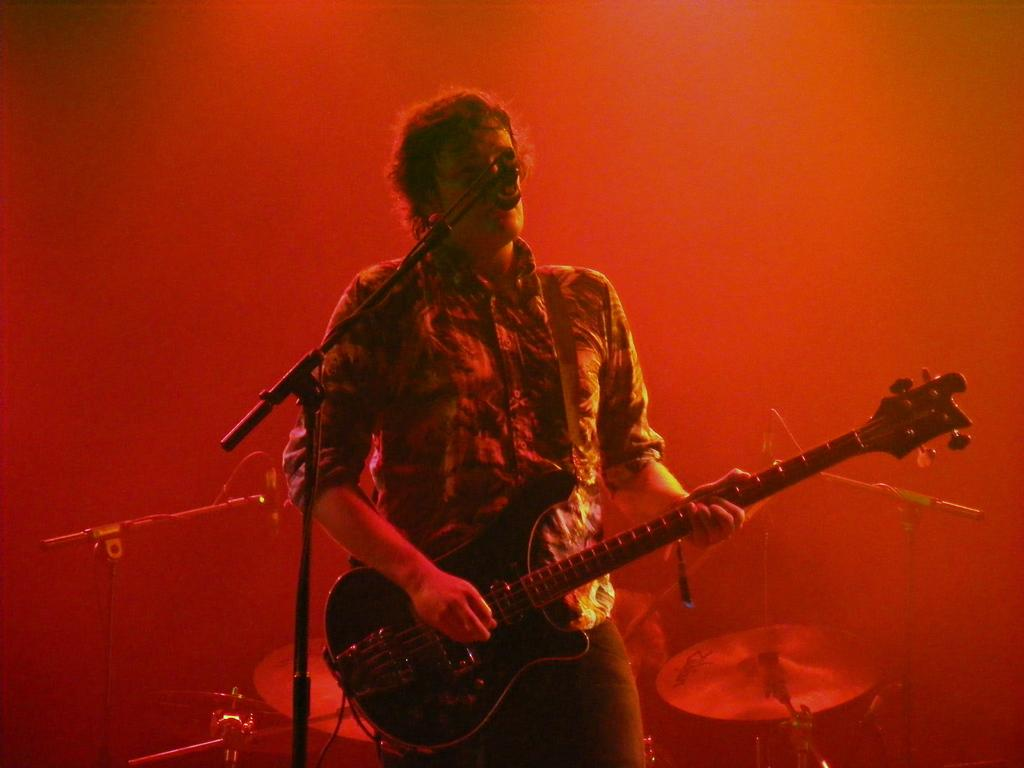What is the man in the image doing? The man is playing a guitar in the image. What object is in the foreground of the image? There is a microphone in the foreground of the image. What musical instrument can be seen in the background of the image? There are drums in the background of the image. Are there any other microphones visible in the image? Yes, there are additional microphones in the background of the image. What type of root can be seen growing near the drums in the image? There is no root visible in the image; it features a man playing a guitar, a microphone in the foreground, drums and additional microphones in the background. Is there a cart carrying a turkey in the image? No, there is no cart or turkey present in the image. 